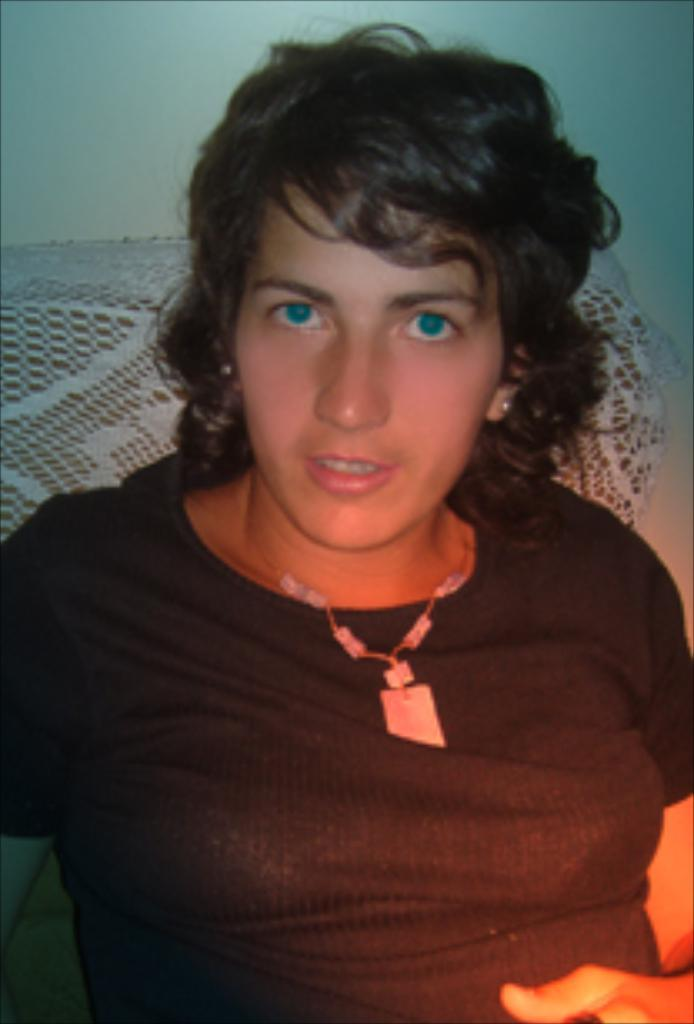Who is the main subject in the image? There is a woman in the image. What is the woman wearing in the image? The woman is wearing a black shirt. What can be seen behind the woman in the image? There is a wall behind the woman. What type of trousers is the woman attempting to wear in the image? There is no indication in the image that the woman is attempting to wear any trousers. 